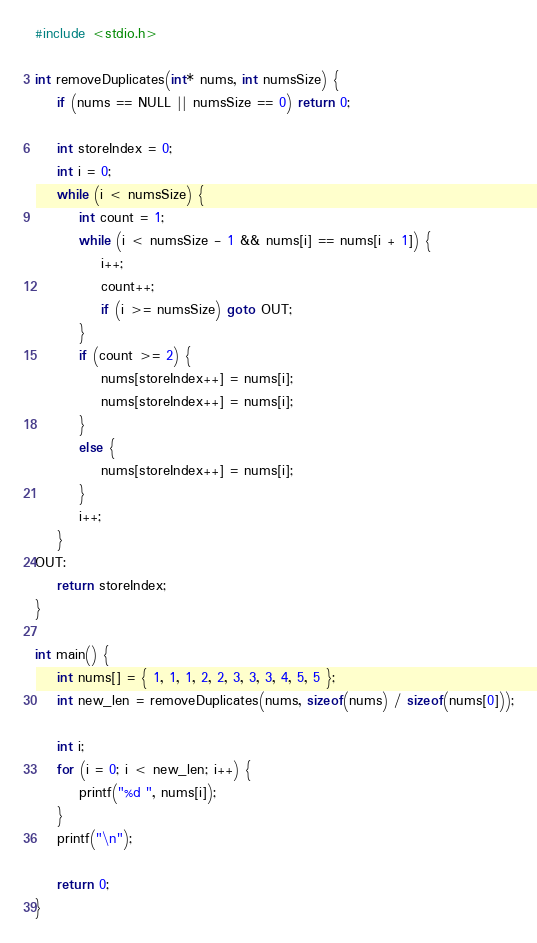<code> <loc_0><loc_0><loc_500><loc_500><_C_>#include <stdio.h>

int removeDuplicates(int* nums, int numsSize) {
    if (nums == NULL || numsSize == 0) return 0;

    int storeIndex = 0;
    int i = 0;
    while (i < numsSize) {
        int count = 1;
        while (i < numsSize - 1 && nums[i] == nums[i + 1]) {
            i++;
            count++;
            if (i >= numsSize) goto OUT;
        }
        if (count >= 2) {
            nums[storeIndex++] = nums[i];
            nums[storeIndex++] = nums[i];
        }
        else {
            nums[storeIndex++] = nums[i];
        }
        i++;
    }
OUT:
    return storeIndex;
}

int main() {
    int nums[] = { 1, 1, 1, 2, 2, 3, 3, 3, 4, 5, 5 };
    int new_len = removeDuplicates(nums, sizeof(nums) / sizeof(nums[0]));

    int i;
    for (i = 0; i < new_len; i++) {
        printf("%d ", nums[i]);
    }
    printf("\n");

    return 0;
}
</code> 